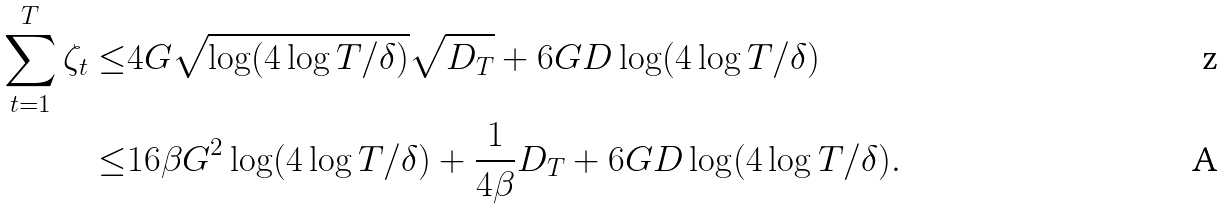Convert formula to latex. <formula><loc_0><loc_0><loc_500><loc_500>\sum _ { t = 1 } ^ { T } \zeta _ { t } \leq & 4 G \sqrt { \log ( 4 \log T / \delta ) } \sqrt { D _ { T } } + 6 G D \log ( 4 \log T / \delta ) \\ \leq & 1 6 \beta G ^ { 2 } \log ( 4 \log T / \delta ) + \frac { 1 } { 4 \beta } D _ { T } + 6 G D \log ( 4 \log T / \delta ) .</formula> 